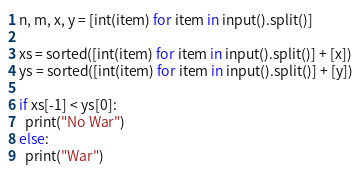<code> <loc_0><loc_0><loc_500><loc_500><_Python_>n, m, x, y = [int(item) for item in input().split()]

xs = sorted([int(item) for item in input().split()] + [x])
ys = sorted([int(item) for item in input().split()] + [y])

if xs[-1] < ys[0]:
  print("No War")
else:
  print("War")</code> 